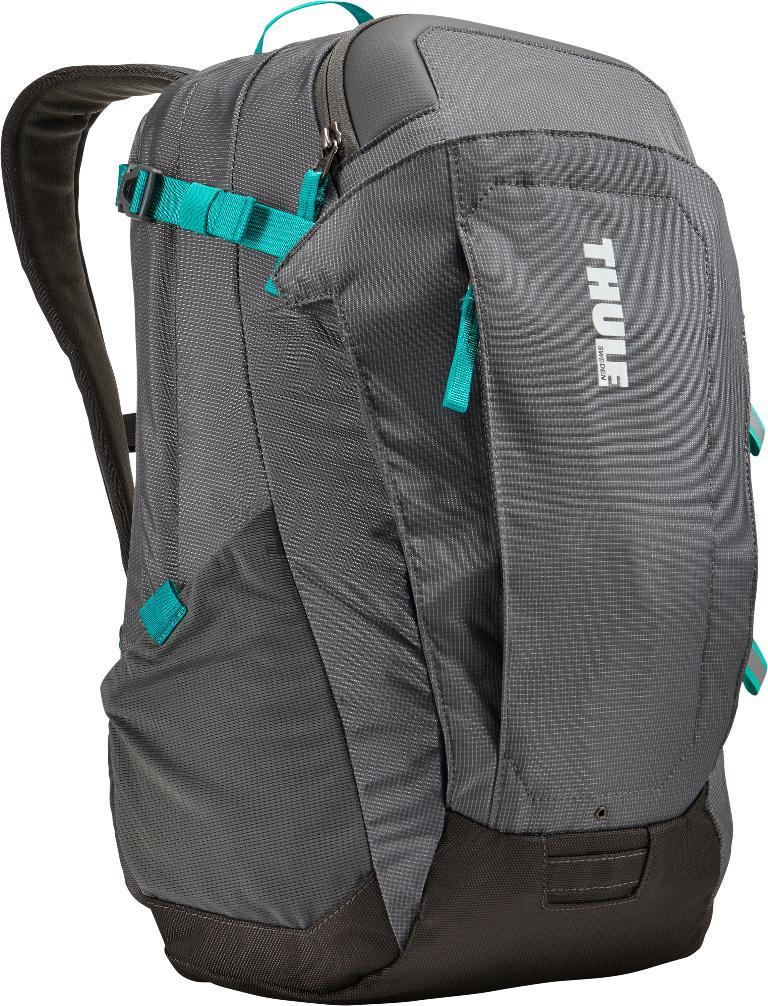<image>
Write a terse but informative summary of the picture. Gray and teal thule backpack sitting alone with a white background 